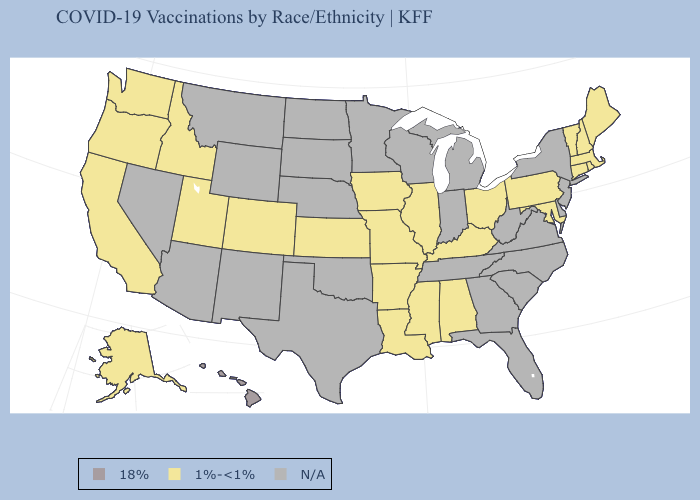What is the lowest value in the MidWest?
Concise answer only. 1%-<1%. Name the states that have a value in the range N/A?
Short answer required. Arizona, Delaware, Florida, Georgia, Indiana, Michigan, Minnesota, Montana, Nebraska, Nevada, New Jersey, New Mexico, New York, North Carolina, North Dakota, Oklahoma, South Carolina, South Dakota, Tennessee, Texas, Virginia, West Virginia, Wisconsin, Wyoming. What is the highest value in states that border Oregon?
Be succinct. 1%-<1%. What is the value of Wyoming?
Short answer required. N/A. Which states have the highest value in the USA?
Give a very brief answer. Hawaii. What is the highest value in states that border Georgia?
Quick response, please. 1%-<1%. What is the value of Alabama?
Write a very short answer. 1%-<1%. What is the value of Arizona?
Short answer required. N/A. Which states hav the highest value in the MidWest?
Quick response, please. Illinois, Iowa, Kansas, Missouri, Ohio. What is the lowest value in the USA?
Give a very brief answer. 1%-<1%. Which states have the lowest value in the USA?
Answer briefly. Alabama, Alaska, Arkansas, California, Colorado, Connecticut, Idaho, Illinois, Iowa, Kansas, Kentucky, Louisiana, Maine, Maryland, Massachusetts, Mississippi, Missouri, New Hampshire, Ohio, Oregon, Pennsylvania, Rhode Island, Utah, Vermont, Washington. What is the value of Virginia?
Quick response, please. N/A. 